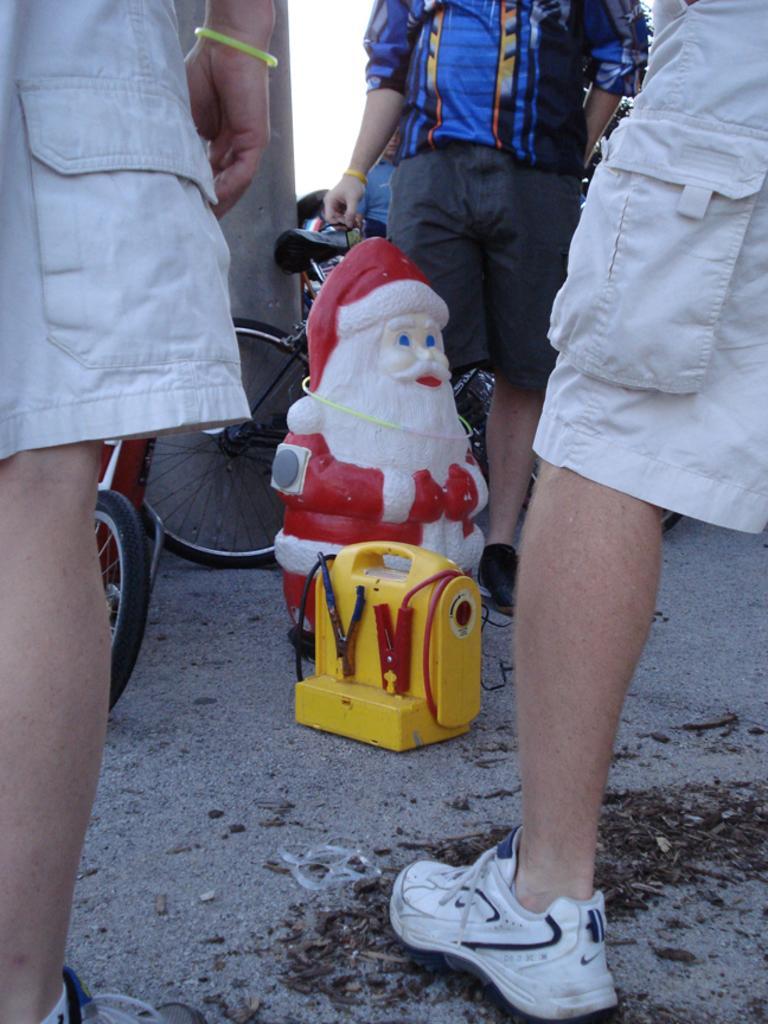How would you summarize this image in a sentence or two? In the center of the image we can see some toys placed on the ground. We can also see some people standing beside them. We can also see a wall and the sky. 